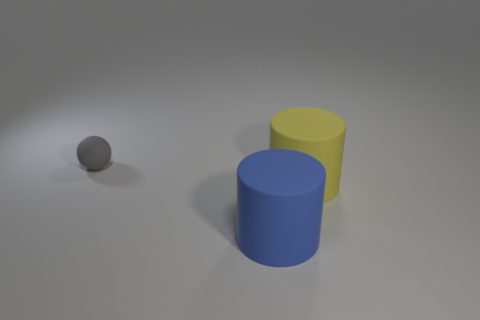How many matte things are yellow objects or blue objects?
Your answer should be very brief. 2. What is the shape of the object to the left of the cylinder on the left side of the yellow matte thing?
Provide a succinct answer. Sphere. Is the number of balls right of the large yellow cylinder less than the number of big blue cylinders?
Your answer should be very brief. Yes. What is the shape of the large yellow object?
Make the answer very short. Cylinder. What size is the matte thing that is in front of the large yellow thing?
Your answer should be compact. Large. What color is the other rubber thing that is the same size as the blue matte object?
Your answer should be very brief. Yellow. Are there fewer small spheres in front of the tiny gray matte object than large cylinders behind the blue rubber object?
Ensure brevity in your answer.  Yes. What is the thing that is both to the left of the yellow object and in front of the sphere made of?
Make the answer very short. Rubber. Does the tiny matte object have the same shape as the big object that is to the left of the large yellow rubber thing?
Provide a short and direct response. No. What number of other objects are the same size as the sphere?
Your answer should be compact. 0. 